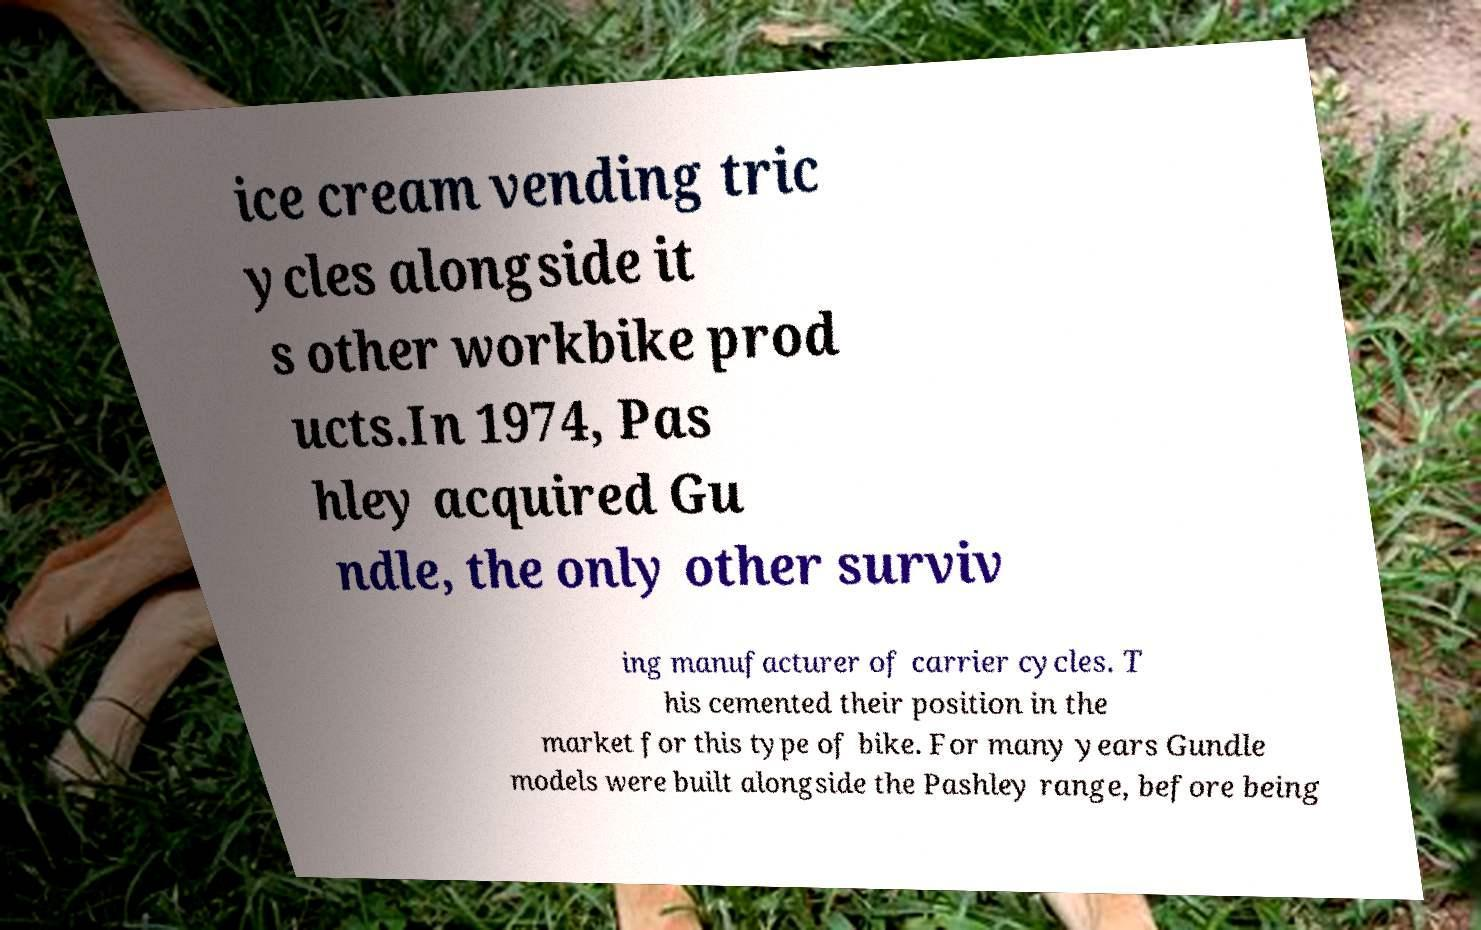What messages or text are displayed in this image? I need them in a readable, typed format. ice cream vending tric ycles alongside it s other workbike prod ucts.In 1974, Pas hley acquired Gu ndle, the only other surviv ing manufacturer of carrier cycles. T his cemented their position in the market for this type of bike. For many years Gundle models were built alongside the Pashley range, before being 